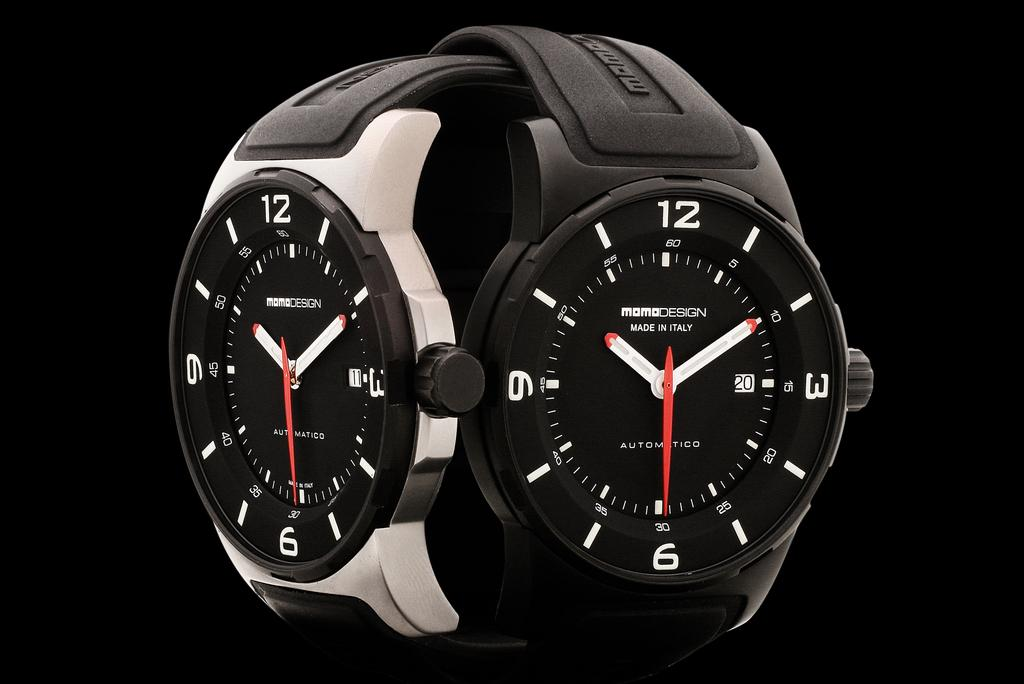<image>
Describe the image concisely. Two intertwined watches, including a black Momodesign made in Italy. 